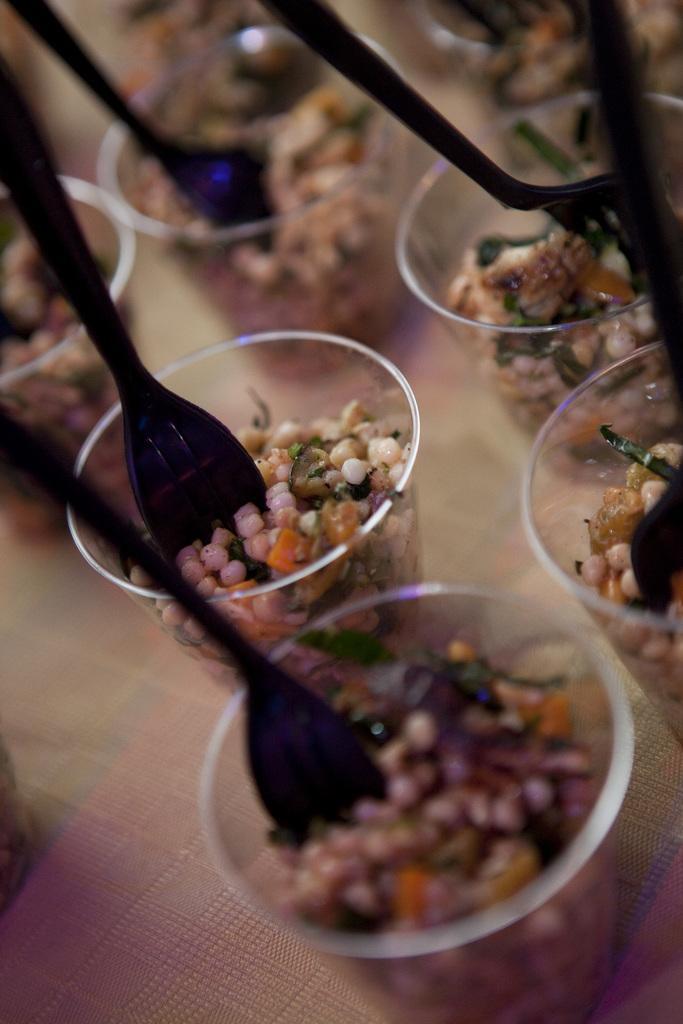Can you describe this image briefly? In this picture, we see the glasses containing food or eatables and spoons are placed on the table. In the background, it is blurred. 